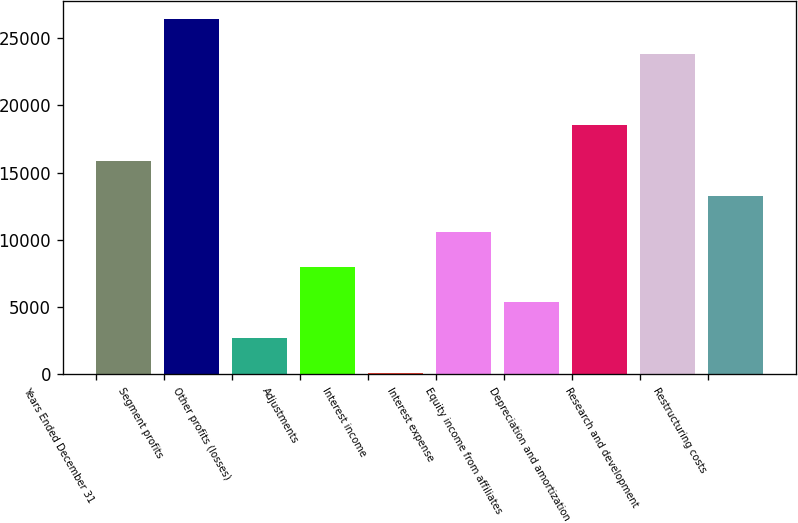<chart> <loc_0><loc_0><loc_500><loc_500><bar_chart><fcel>Years Ended December 31<fcel>Segment profits<fcel>Other profits (losses)<fcel>Adjustments<fcel>Interest income<fcel>Interest expense<fcel>Equity income from affiliates<fcel>Depreciation and amortization<fcel>Research and development<fcel>Restructuring costs<nl><fcel>15888.8<fcel>26426<fcel>2717.3<fcel>7985.9<fcel>83<fcel>10620.2<fcel>5351.6<fcel>18523.1<fcel>23791.7<fcel>13254.5<nl></chart> 